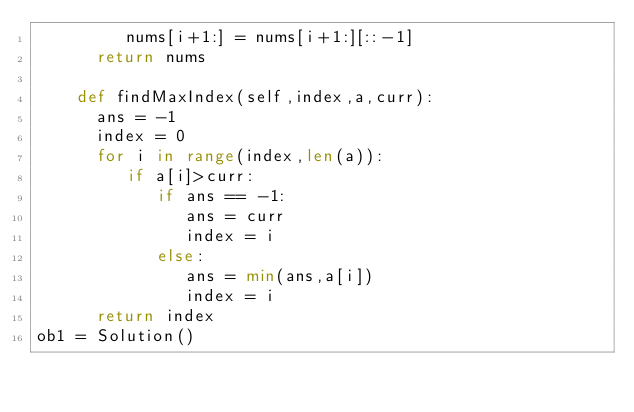Convert code to text. <code><loc_0><loc_0><loc_500><loc_500><_Python_>         nums[i+1:] = nums[i+1:][::-1]
      return nums
  
    def findMaxIndex(self,index,a,curr):
      ans = -1
      index = 0
      for i in range(index,len(a)):
         if a[i]>curr:
            if ans == -1:
               ans = curr
               index = i
            else:
               ans = min(ans,a[i])
               index = i
      return index
ob1 = Solution()
</code> 